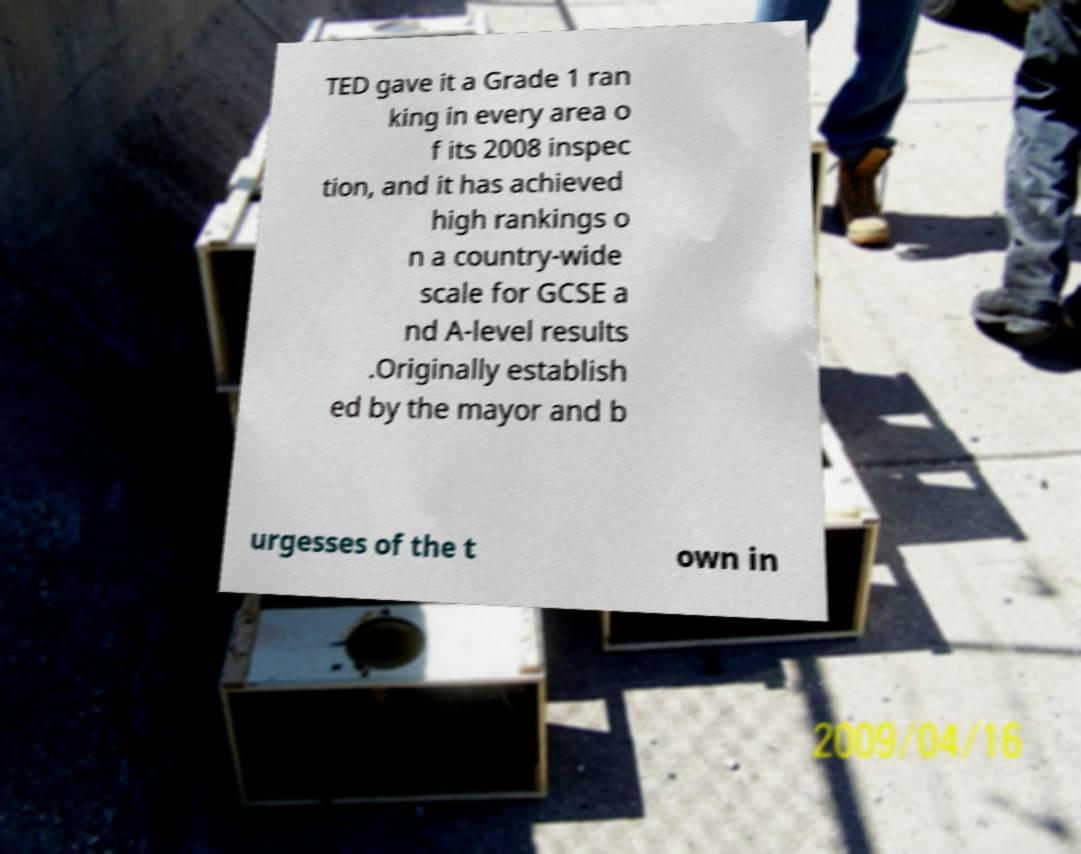Please read and relay the text visible in this image. What does it say? TED gave it a Grade 1 ran king in every area o f its 2008 inspec tion, and it has achieved high rankings o n a country-wide scale for GCSE a nd A-level results .Originally establish ed by the mayor and b urgesses of the t own in 